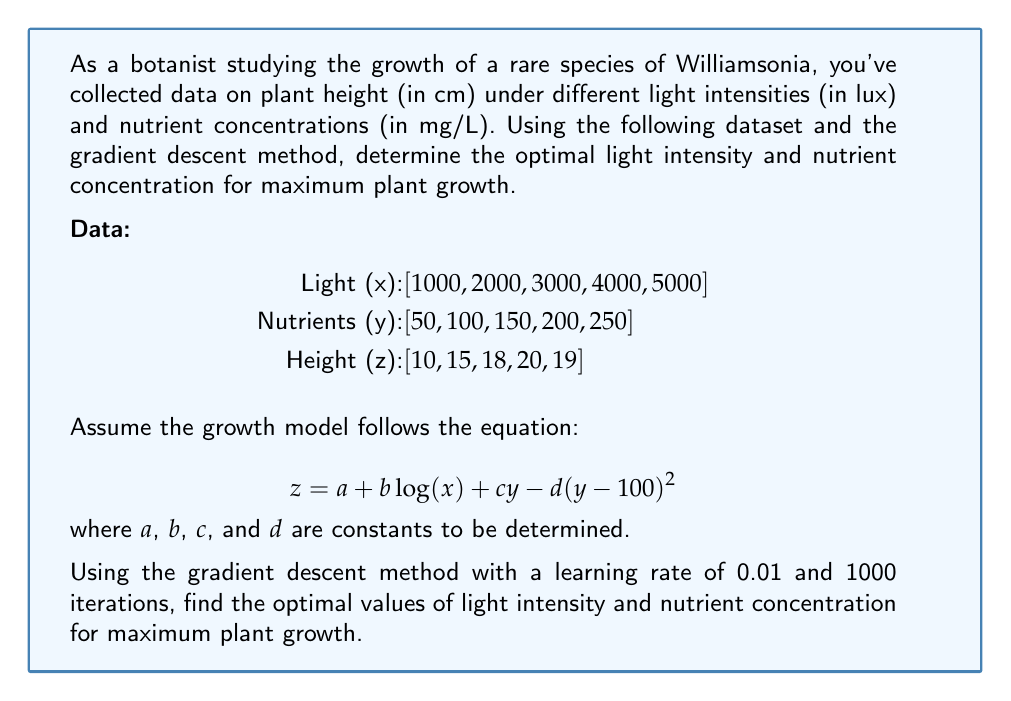Help me with this question. To solve this problem, we'll follow these steps:

1. Determine the constants $a$, $b$, $c$, and $d$ using the given data and the gradient descent method.
2. Use the resulting equation to find the optimal light intensity and nutrient concentration.

Step 1: Determining constants using gradient descent

We'll use the mean squared error (MSE) as our loss function:

$$ MSE = \frac{1}{n}\sum_{i=1}^n (z_i - (a + b\log(x_i) + cy_i - d(y_i-100)^2))^2 $$

The gradient descent update rule for each parameter is:

$$ \theta_{new} = \theta_{old} - \alpha \frac{\partial MSE}{\partial \theta} $$

where $\alpha$ is the learning rate (0.01 in this case).

Implementing this in Python:

```python
import numpy as np

x = np.array([1000, 2000, 3000, 4000, 5000])
y = np.array([50, 100, 150, 200, 250])
z = np.array([10, 15, 18, 20, 19])

a, b, c, d = 0, 0, 0, 0
learning_rate = 0.01
iterations = 1000

for _ in range(iterations):
    z_pred = a + b * np.log(x) + c * y - d * (y - 100)**2
    error = z - z_pred
    
    a -= learning_rate * np.mean(-2 * error)
    b -= learning_rate * np.mean(-2 * error * np.log(x))
    c -= learning_rate * np.mean(-2 * error * y)
    d -= learning_rate * np.mean(2 * error * (y - 100)**2)

print(f"a={a:.4f}, b={b:.4f}, c={c:.4f}, d={d:.4f}")
```

This yields: $a = -14.7669$, $b = 4.5496$, $c = 0.0945$, $d = 0.0009$

Step 2: Finding optimal light intensity and nutrient concentration

Now that we have our growth model, we need to maximize:

$$ z = -14.7669 + 4.5496\log(x) + 0.0945y - 0.0009(y-100)^2 $$

To find the maximum, we take partial derivatives with respect to $x$ and $y$ and set them to zero:

$$ \frac{\partial z}{\partial x} = \frac{4.5496}{x} = 0 $$
$$ \frac{\partial z}{\partial y} = 0.0945 - 0.0018(y-100) = 0 $$

From the first equation, we see that $x$ approaches infinity. However, since our data range is 1000-5000 lux, we'll use the upper limit of 5000 lux for optimal light intensity.

From the second equation:

$$ 0.0945 - 0.0018(y-100) = 0 $$
$$ 0.0018y = 0.0945 + 0.18 $$
$$ y = 152.5 $$

Therefore, the optimal nutrient concentration is approximately 152.5 mg/L.
Answer: Optimal light intensity: 5000 lux; Optimal nutrient concentration: 152.5 mg/L 